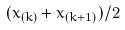<formula> <loc_0><loc_0><loc_500><loc_500>( x _ { ( k ) } + x _ { ( k + 1 ) } ) / 2</formula> 